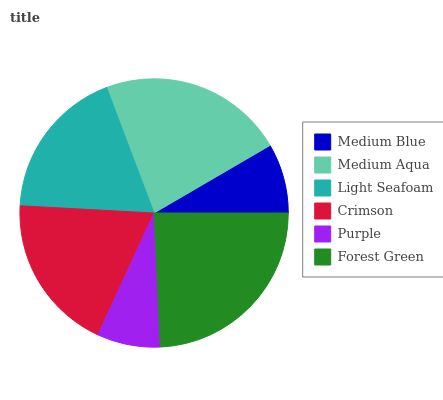Is Purple the minimum?
Answer yes or no. Yes. Is Forest Green the maximum?
Answer yes or no. Yes. Is Medium Aqua the minimum?
Answer yes or no. No. Is Medium Aqua the maximum?
Answer yes or no. No. Is Medium Aqua greater than Medium Blue?
Answer yes or no. Yes. Is Medium Blue less than Medium Aqua?
Answer yes or no. Yes. Is Medium Blue greater than Medium Aqua?
Answer yes or no. No. Is Medium Aqua less than Medium Blue?
Answer yes or no. No. Is Crimson the high median?
Answer yes or no. Yes. Is Light Seafoam the low median?
Answer yes or no. Yes. Is Light Seafoam the high median?
Answer yes or no. No. Is Medium Blue the low median?
Answer yes or no. No. 